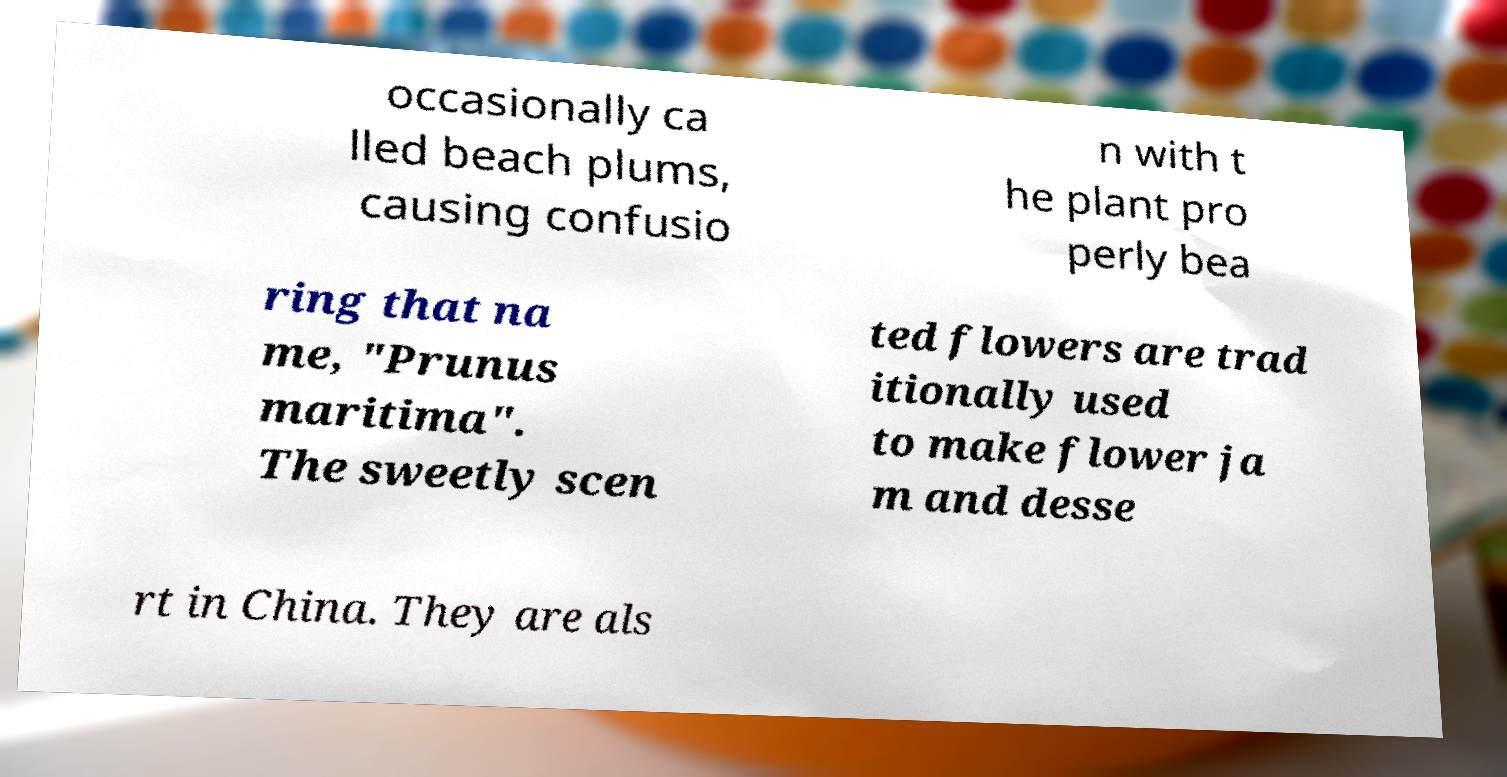Can you accurately transcribe the text from the provided image for me? occasionally ca lled beach plums, causing confusio n with t he plant pro perly bea ring that na me, "Prunus maritima". The sweetly scen ted flowers are trad itionally used to make flower ja m and desse rt in China. They are als 